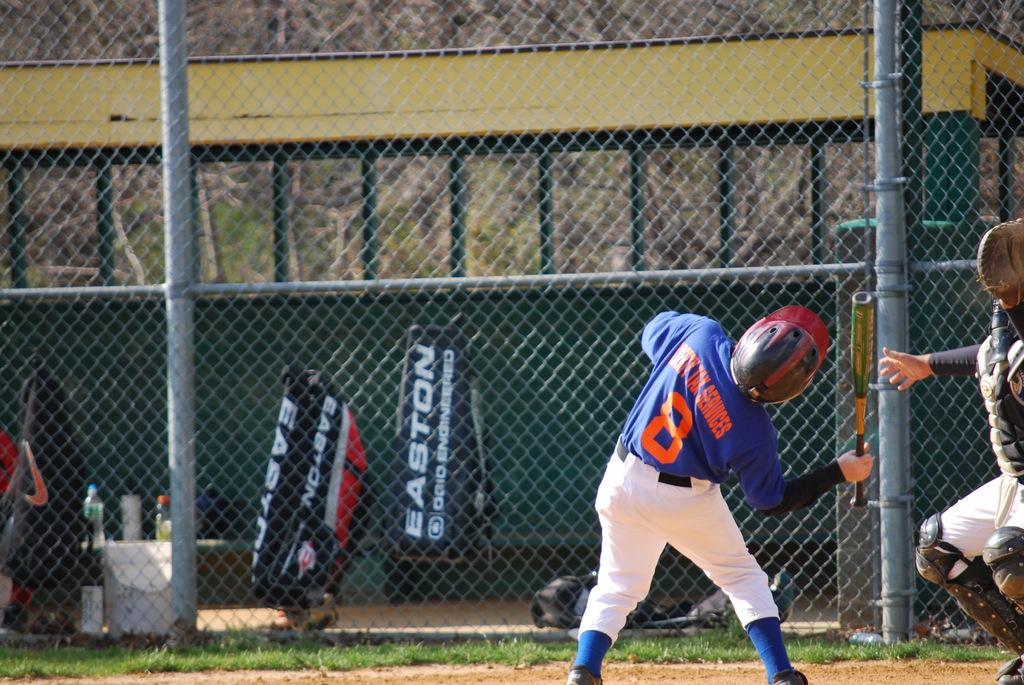<image>
Render a clear and concise summary of the photo. At home plate, player number 8 bends back as he holds a bat. 